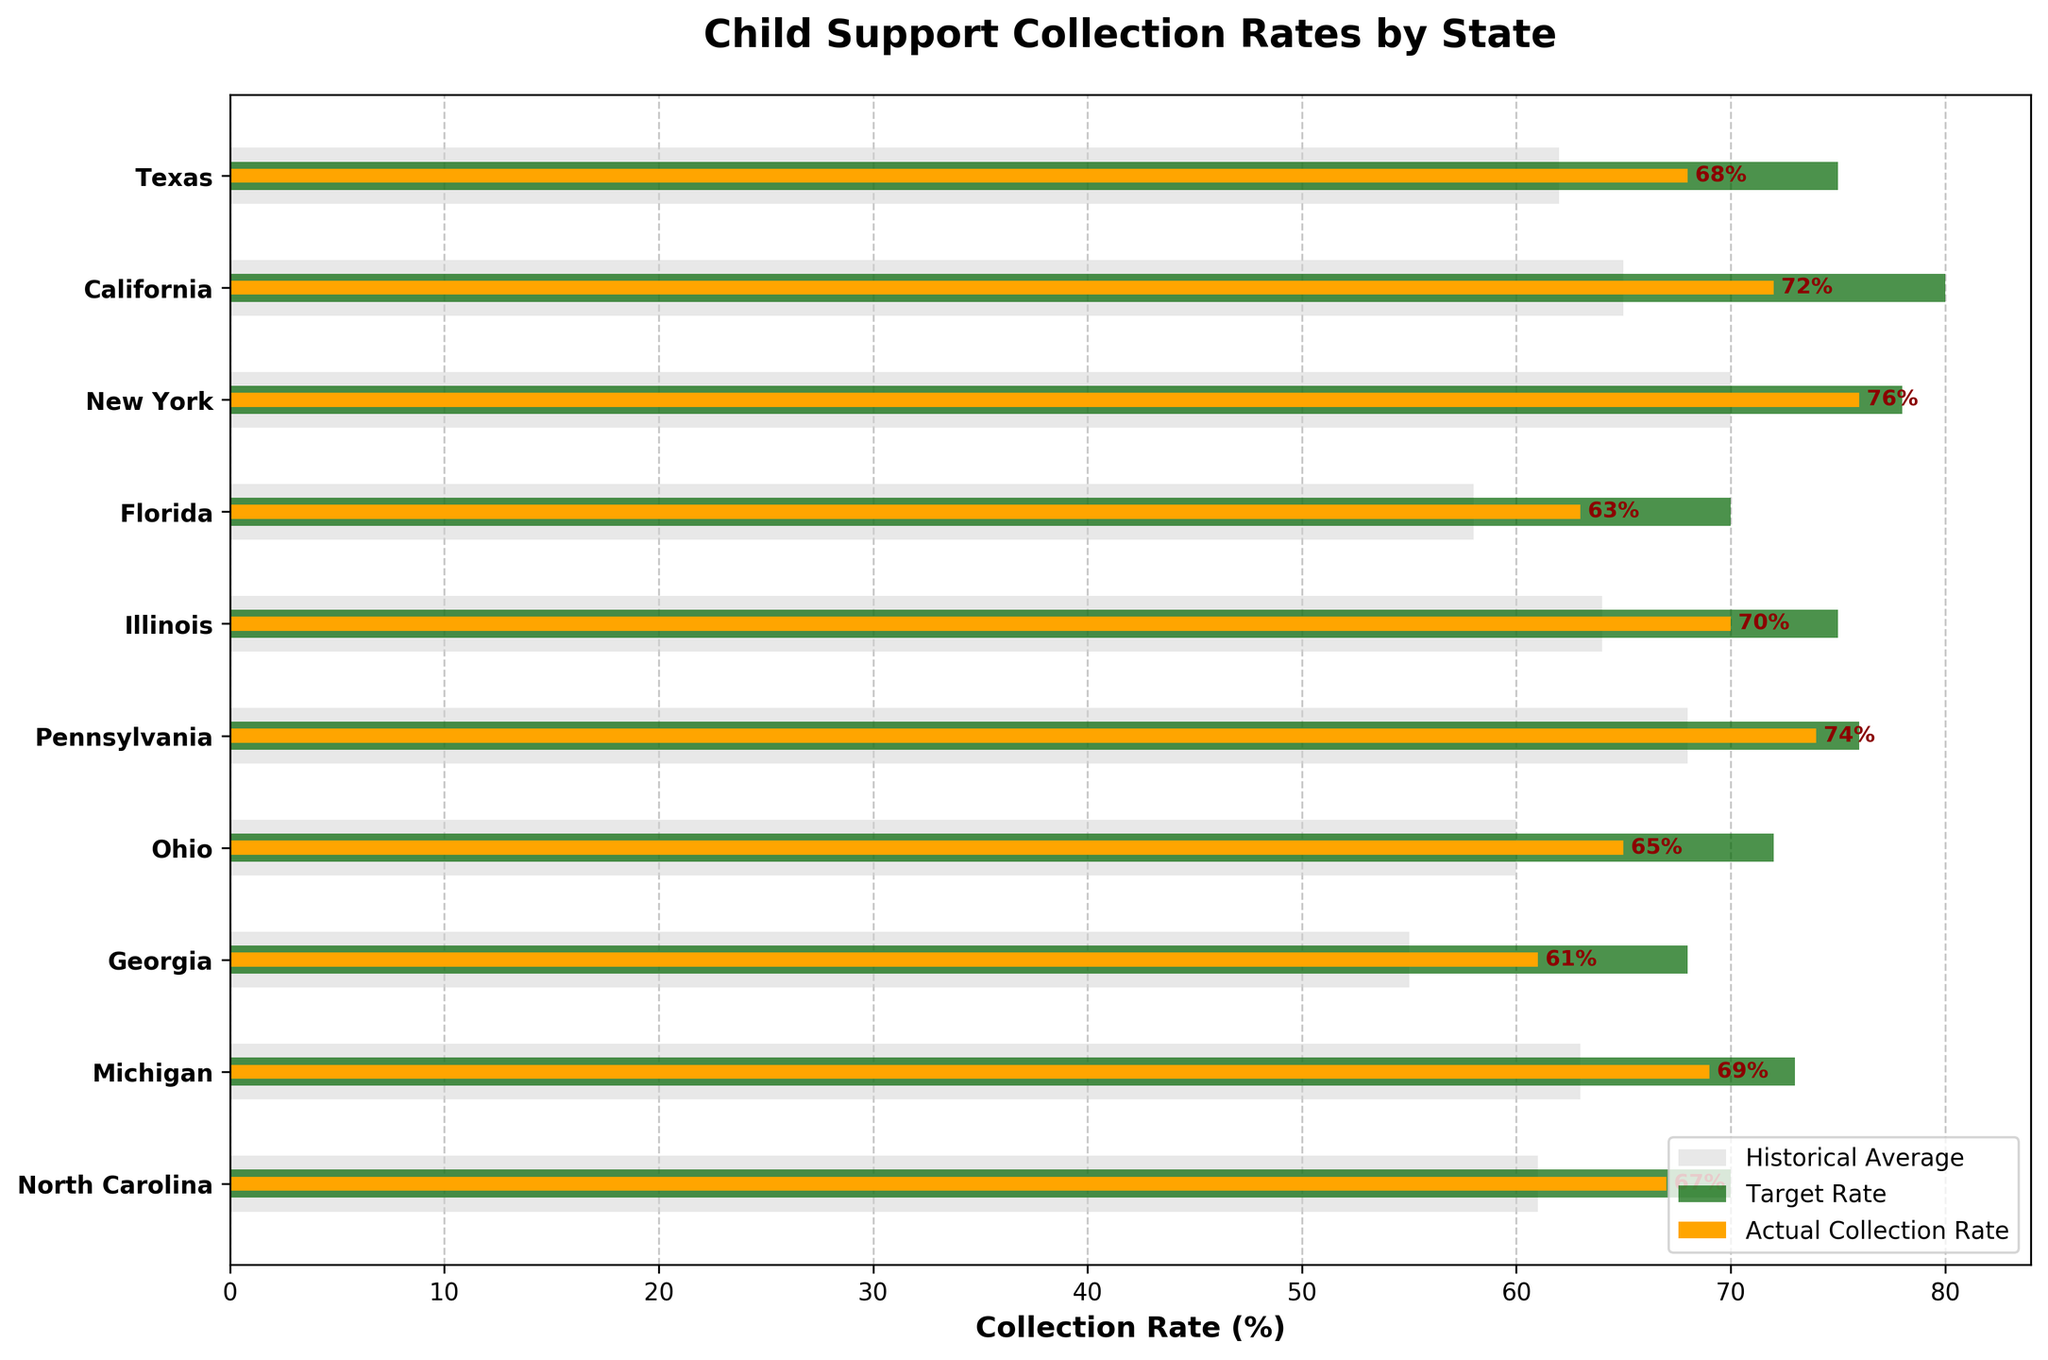What is the child support collection rate for California? Look at the bar labeled 'California' and find the value on the 'Actual Collection Rate' bar.
Answer: 72% How does the actual collection rate for Texas compare to the target rate for Texas? Identify the values for Texas in both 'Actual Collection Rate' (68%) and 'Target Rate' (75%). Compare the two values.
Answer: 7% less Which state has the highest actual collection rate? Compare the heights of the 'Actual Collection Rate' bars to find the maximum.
Answer: New York Which states exceed their historical average in actual collection rate? Compare the 'Actual Collection Rate' with the 'Historical Average' for each state.
Answer: Texas, California, New York, Florida, Illinois, Pennsylvania, Michigan, North Carolina What is the difference between the target rate and actual collection rate in Florida? Subtract the 'Actual Collection Rate' for Florida (63%) from the 'Target Rate' (70%).
Answer: 7% How many states have an actual collection rate of 70% or higher? Count the states where the 'Actual Collection Rate' bar reaches 70% or more.
Answer: 5 Which state is closest to meeting its target rate? Determine the state with the smallest gap between the 'Actual Collection Rate' and 'Target Rate'.
Answer: New York What is the average historical collection rate across all states? Sum the 'Historical Average' for all states and divide by the number of states (629 / 10).
Answer: 62.9% What can you infer about child support collection efforts in Georgia based on the chart? Compare Georgia's actual collection rate (61%) to its historical average (55%) and target rate (68%). The actual collection rate is above the historical average but below the target rate.
Answer: Above historical, below target How much higher is New York's actual collection rate compared to Ohio's actual collection rate? Subtract Ohio's 'Actual Collection Rate' (65%) from New York's 'Actual Collection Rate' (76%).
Answer: 11% 